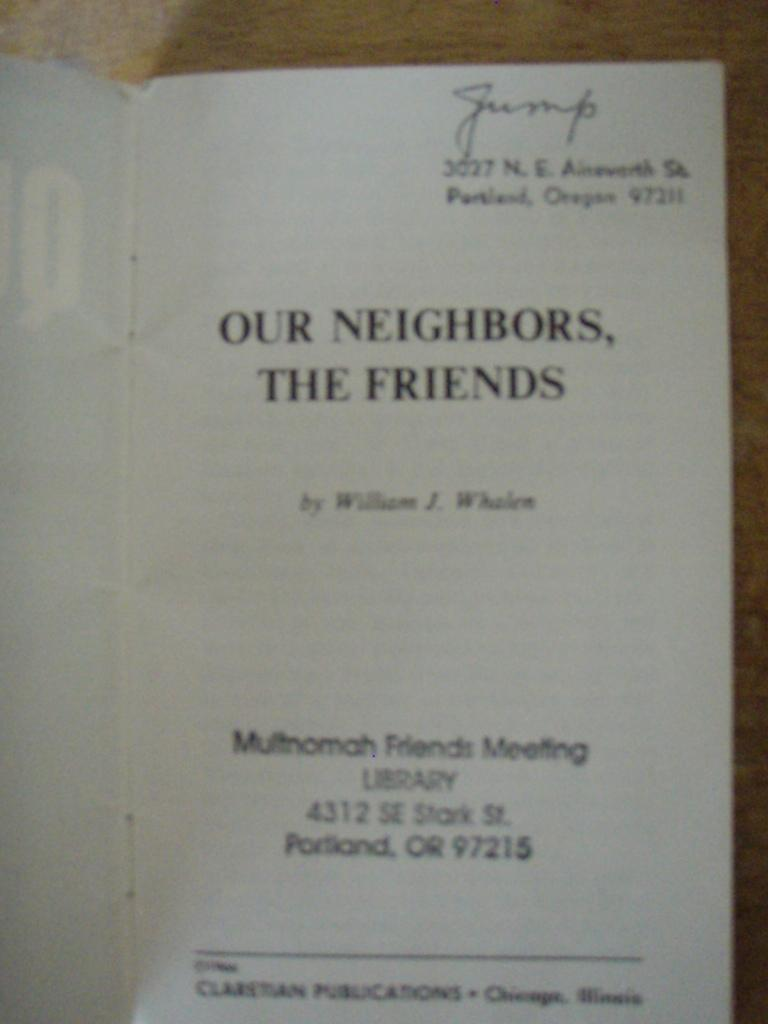<image>
Describe the image concisely. A meeting syllabus titled Our Neighbors, the Friends 